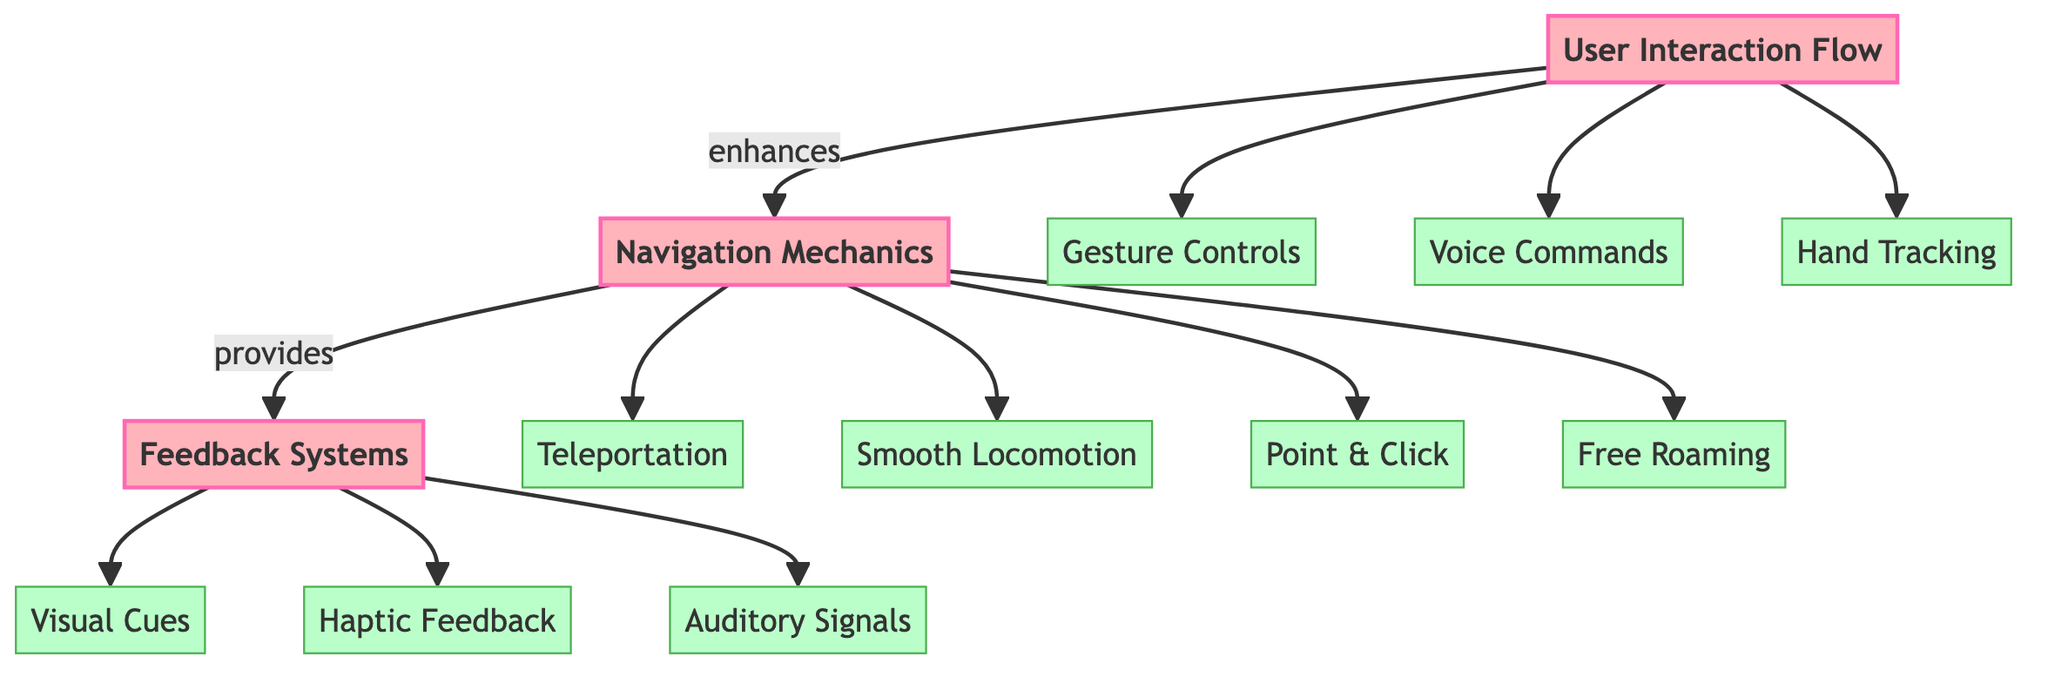What is the first node in the diagram? The first node in the diagram, positioned at the top, is labeled "User Interaction Flow," representing the starting point of the UX design process in VR.
Answer: User Interaction Flow How many main nodes are there in the diagram? The diagram contains three main nodes: "User Interaction Flow," "Navigation Mechanics," and "Feedback Systems."
Answer: 3 Which node provides feedback systems? The "Navigation Mechanics" node provides the "Feedback Systems" node, indicating that navigation is interlinked with user feedback mechanisms within the VR experience.
Answer: Navigation Mechanics What type of control is associated with user interaction? The user interaction section lists "Gesture Controls," "Voice Commands," and "Hand Tracking" as the primary methods for interacting in the VR environment.
Answer: Gesture Controls What is the relationship between user interaction flow and navigation mechanics? The arrow from "User Interaction Flow" to "Navigation Mechanics" labeled "enhances" indicates that improved user interaction directly enhances the navigation experience in VR.
Answer: enhances Which type of locomotion allows for free movement? The node labeled "Free Roaming" under "Navigation Mechanics" indicates a locomotion type that permits unrestricted movement in the VR environment.
Answer: Free Roaming How many feedback mechanisms are listed? The diagram shows three types of feedback mechanisms: "Visual Cues," "Haptic Feedback," and "Auditory Signals," providing different forms of feedback to the users.
Answer: 3 Which component provides auditory signals? "Auditory Signals" is a specific feedback mechanism listed under the "Feedback Systems" node, indicating the type of feedback that involves sound cues in the VR experience.
Answer: Auditory Signals What type of controls is used to navigate? Under "Navigation Mechanics," the controls listed include "Teleportation," "Smooth Locomotion," "Point & Click," and "Free Roaming," which describe various methods users can navigate through the VR environment.
Answer: Teleportation Which node is enhanced by user interaction flow? The "Navigation Mechanics" node is the section that is enhanced by the "User Interaction Flow," as indicated by the direct connection in the diagram illustrating the impact of user input on navigation.
Answer: Navigation Mechanics 